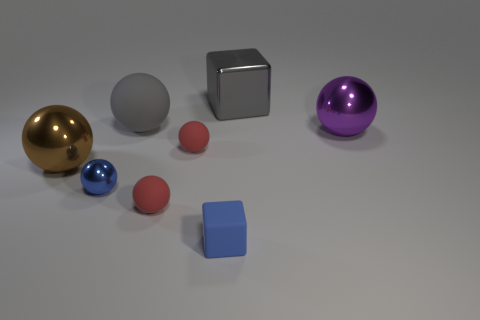Add 1 large metal spheres. How many objects exist? 9 Subtract all small metallic spheres. How many spheres are left? 5 Subtract all blue blocks. How many blocks are left? 1 Subtract all brown cylinders. How many red spheres are left? 2 Subtract all blocks. How many objects are left? 6 Subtract 0 green cylinders. How many objects are left? 8 Subtract 1 blocks. How many blocks are left? 1 Subtract all purple spheres. Subtract all red blocks. How many spheres are left? 5 Subtract all big purple objects. Subtract all blue objects. How many objects are left? 5 Add 4 large metallic spheres. How many large metallic spheres are left? 6 